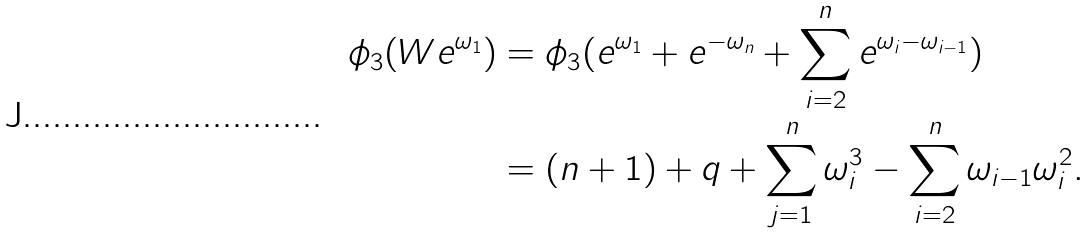Convert formula to latex. <formula><loc_0><loc_0><loc_500><loc_500>\phi _ { 3 } ( W e ^ { \omega _ { 1 } } ) & = \phi _ { 3 } ( e ^ { \omega _ { 1 } } + e ^ { - \omega _ { n } } + \sum _ { i = 2 } ^ { n } e ^ { \omega _ { i } - \omega _ { i - 1 } } ) \\ & = ( n + 1 ) + q + \sum _ { j = 1 } ^ { n } \omega _ { i } ^ { 3 } - \sum _ { i = 2 } ^ { n } \omega _ { i - 1 } \omega _ { i } ^ { 2 } .</formula> 